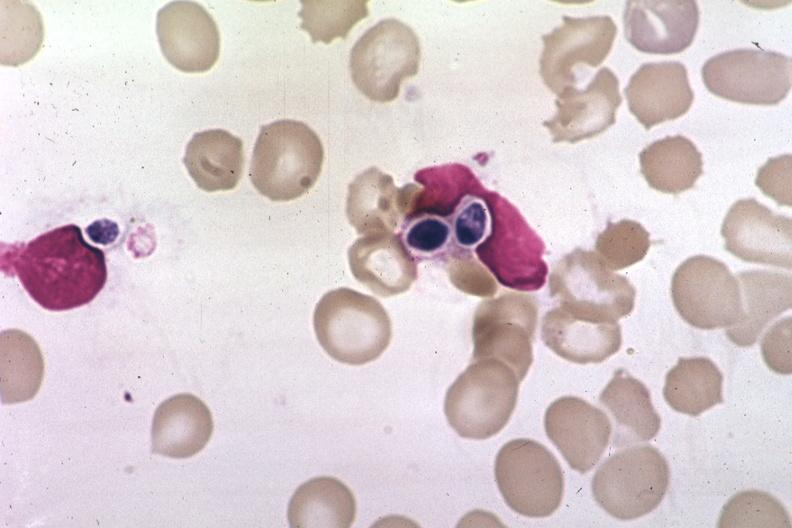what is present?
Answer the question using a single word or phrase. Hematologic 